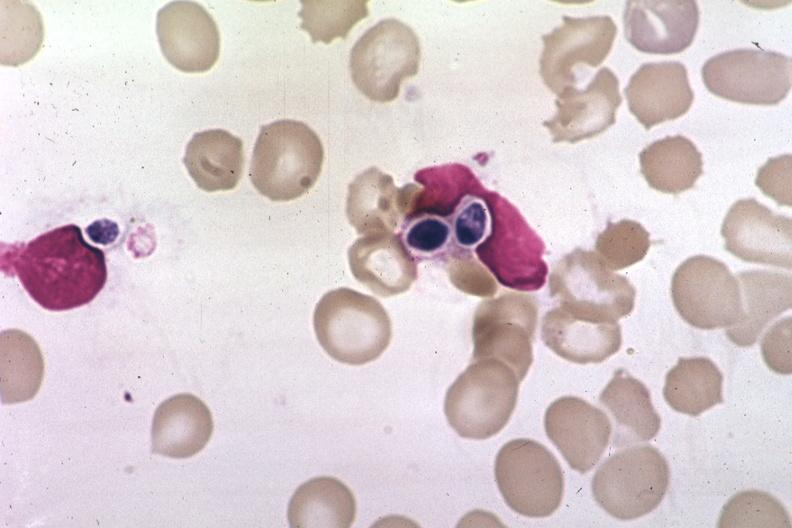what is present?
Answer the question using a single word or phrase. Hematologic 